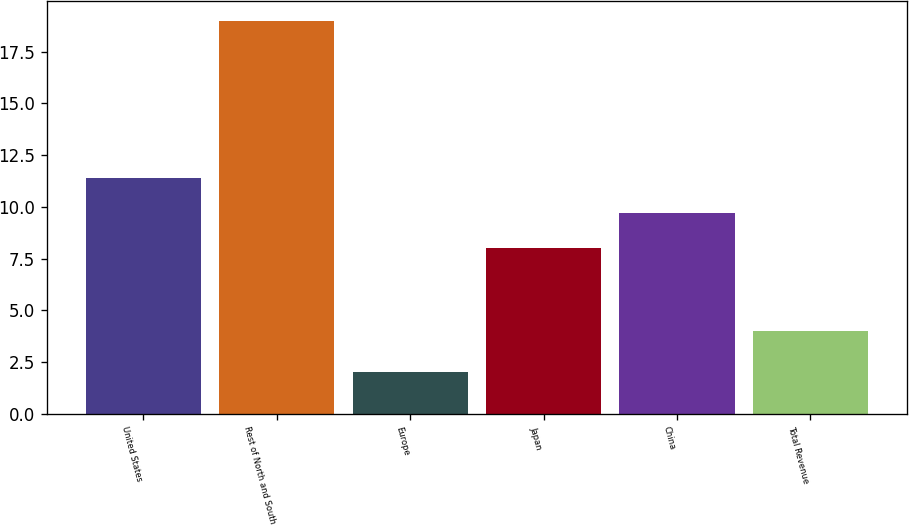<chart> <loc_0><loc_0><loc_500><loc_500><bar_chart><fcel>United States<fcel>Rest of North and South<fcel>Europe<fcel>Japan<fcel>China<fcel>Total Revenue<nl><fcel>11.4<fcel>19<fcel>2<fcel>8<fcel>9.7<fcel>4<nl></chart> 